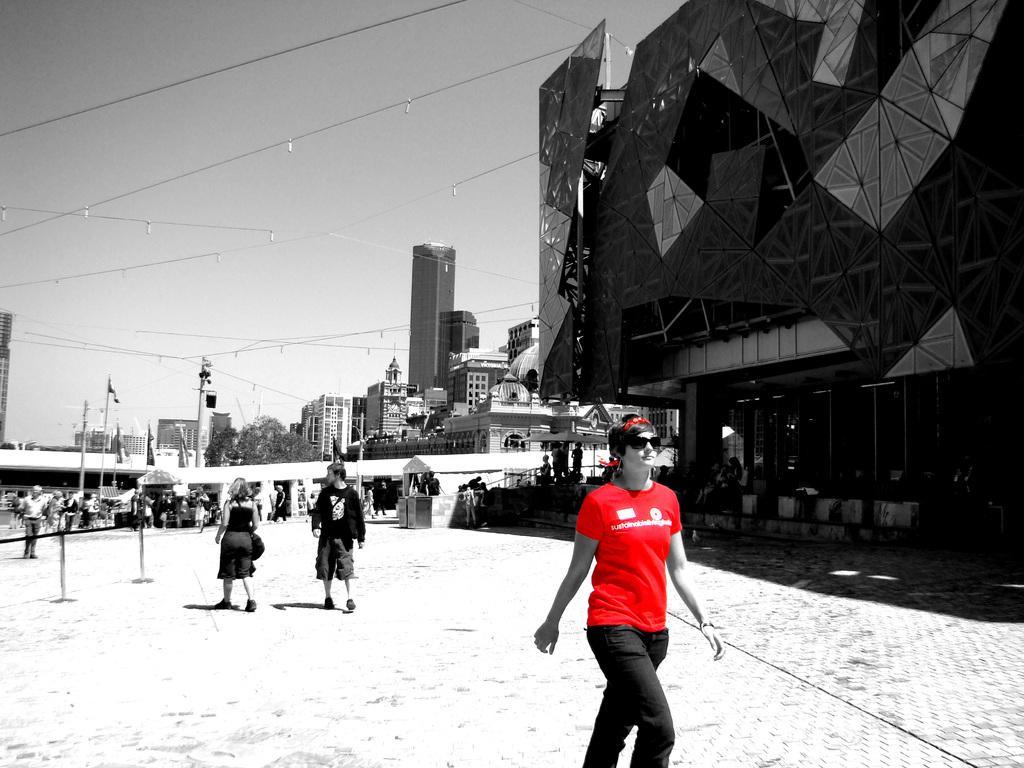Could you give a brief overview of what you see in this image? On the right side a person is walking, this person wore a red color t-shirt and this is the building, at the top it's a sky. 